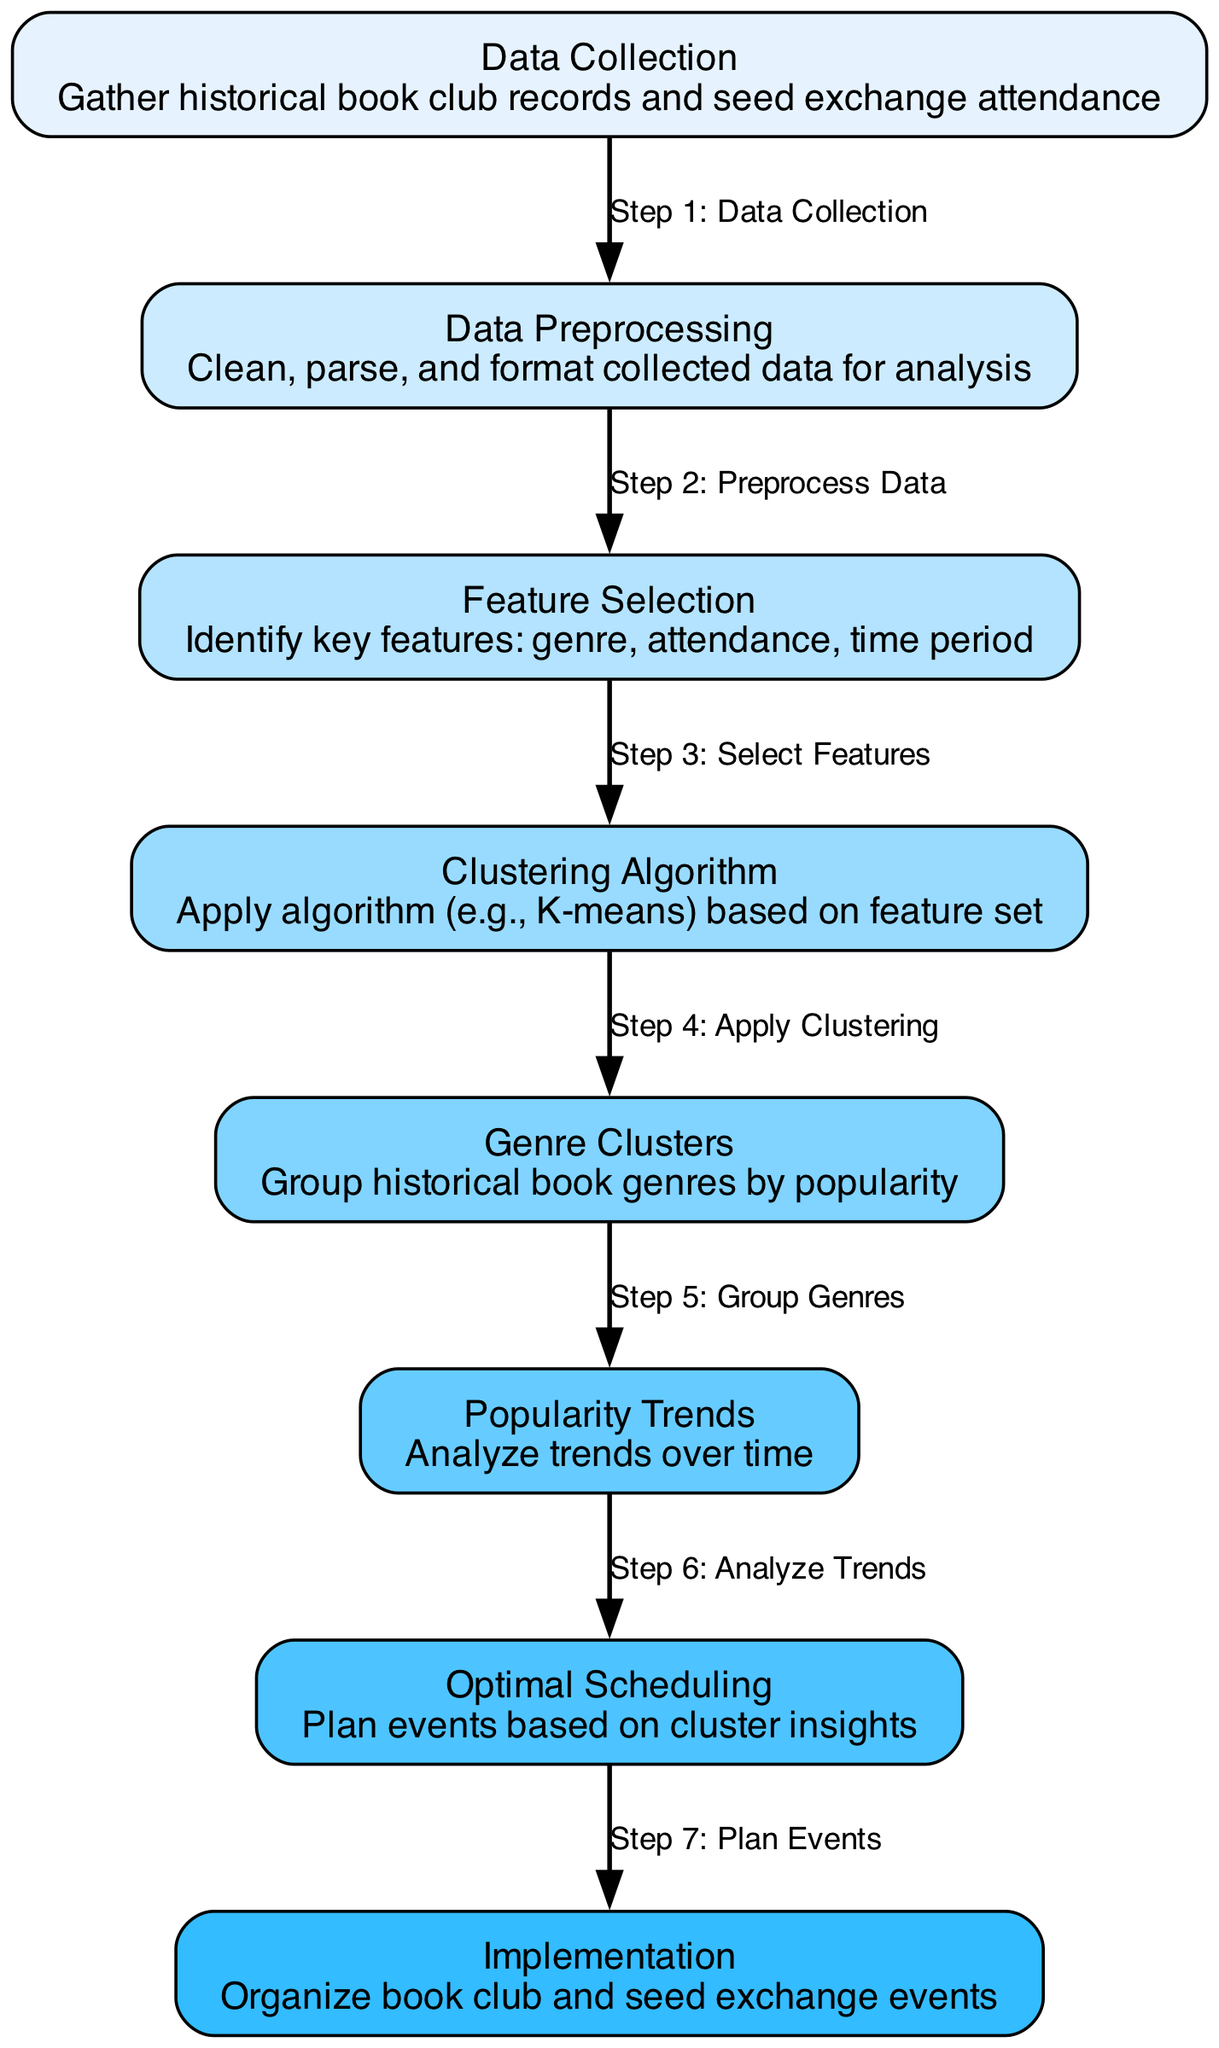What is the first step in the diagram? The first step is represented as "Data Collection". The flow of the diagram clearly shows that Data Collection leads to Data Preprocessing, thus indicating it is the initial step.
Answer: Data Collection How many nodes are in the diagram? By counting all the defined nodes, we see there are a total of 8 nodes present in the diagram according to the data structure provided.
Answer: 8 What is the purpose of the "Clustering Algorithm" node? The node labeled "Clustering Algorithm" describes the action of applying an algorithm (e.g., K-means) based on the selected features, which is pivotal in grouping the genres by popularity.
Answer: Apply clustering Which two nodes are connected by the edge labeled "Step 5: Group Genres"? The edge labeled "Step 5: Group Genres" connects the nodes "Genre Clusters" and "Popularity Trends", indicating the flow from clustering to analyzing trends.
Answer: Genre Clusters and Popularity Trends What happens after "Analyze Trends"? After analyzing the trends in the "Popularity Trends" node, the next step indicated is "Optimal Scheduling", where the insights are utilized for planning events effectively.
Answer: Optimal Scheduling What feature is key to grouping in the "Genre Clusters" node? The key feature in the "Genre Clusters" node refers to "popularity", as it groups historical book genres specifically based on this attribute.
Answer: Popularity How many edges connect the nodes in the diagram? Each connection from one node to another represents an edge, and by analyzing the provided edges, we find that there are a total of 7 edges in the diagram.
Answer: 7 What is the final output in this process? The final output, as described in the diagram, is the "Implementation" node, which refers to organizing the actual events based on the previous analysis.
Answer: Implementation 